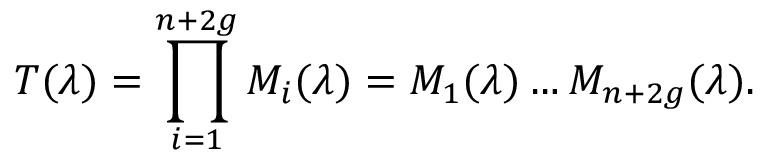Convert formula to latex. <formula><loc_0><loc_0><loc_500><loc_500>T ( \lambda ) = \prod _ { i = 1 } ^ { n + 2 g } { M _ { i } ( \lambda ) } = M _ { 1 } ( \lambda ) \dots M _ { n + 2 g } ( \lambda ) .</formula> 